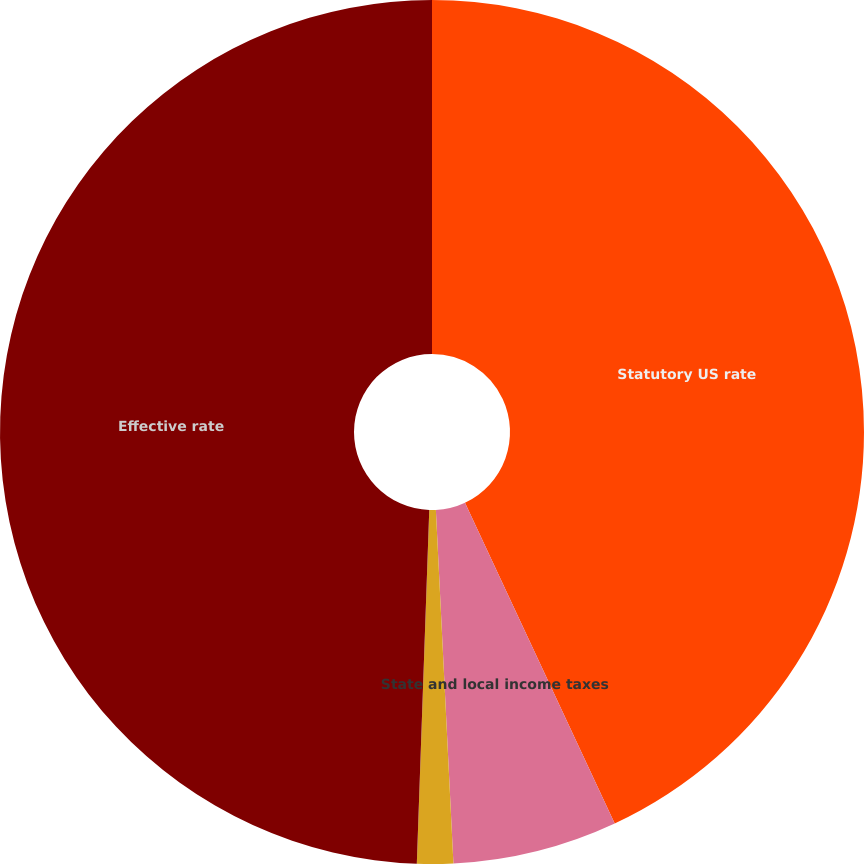Convert chart to OTSL. <chart><loc_0><loc_0><loc_500><loc_500><pie_chart><fcel>Statutory US rate<fcel>State and local income taxes<fcel>Other<fcel>Effective rate<nl><fcel>43.05%<fcel>6.16%<fcel>1.35%<fcel>49.44%<nl></chart> 